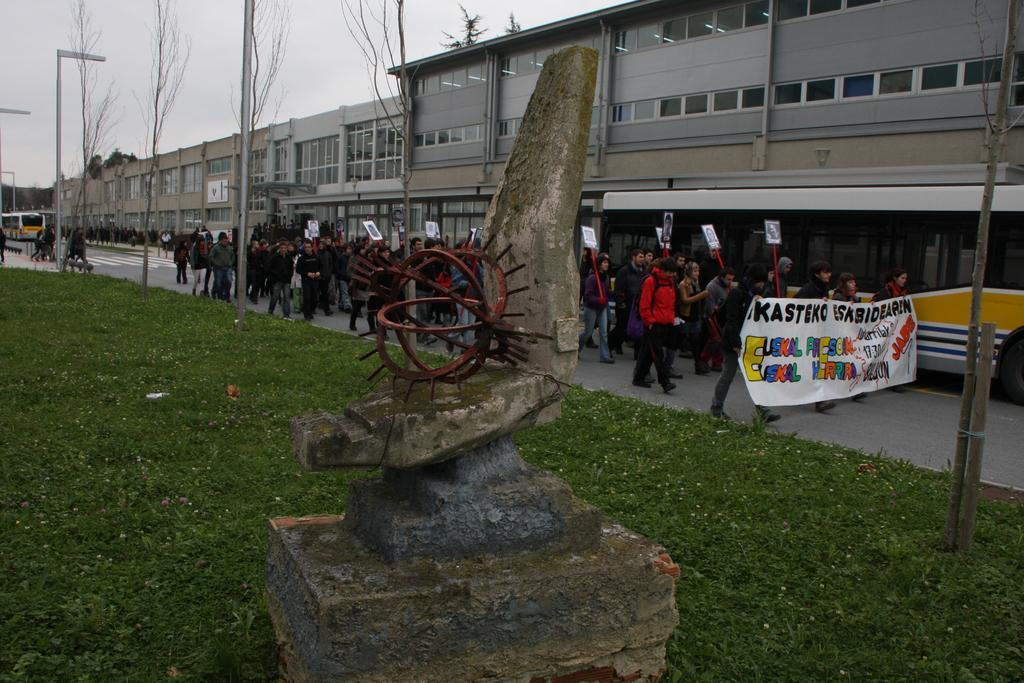Please provide a concise description of this image. In this image at front there is a grass on the surface and there is a rock structure. At the backside people are walking on the road by holding the banners. At the background there are buildings, trees, street lights. At the left side of the image there is a bus on the road. 